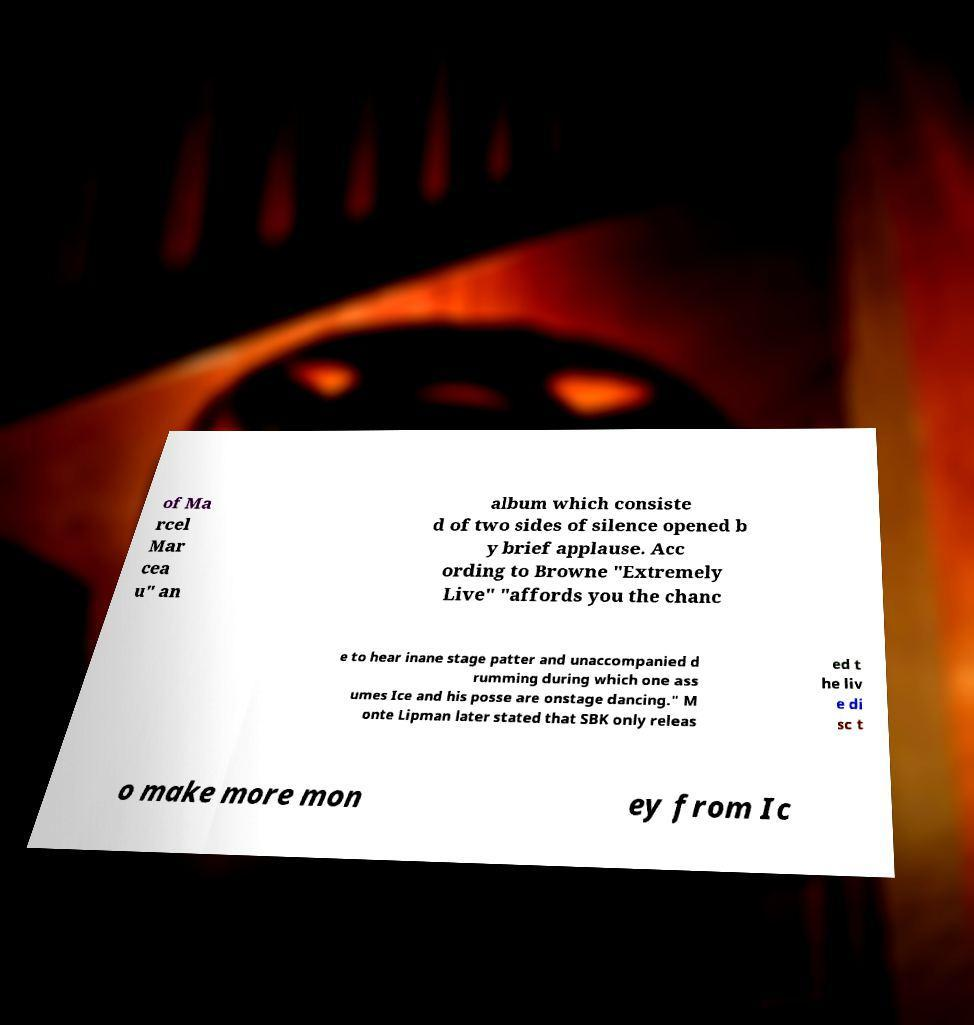I need the written content from this picture converted into text. Can you do that? of Ma rcel Mar cea u" an album which consiste d of two sides of silence opened b y brief applause. Acc ording to Browne "Extremely Live" "affords you the chanc e to hear inane stage patter and unaccompanied d rumming during which one ass umes Ice and his posse are onstage dancing." M onte Lipman later stated that SBK only releas ed t he liv e di sc t o make more mon ey from Ic 